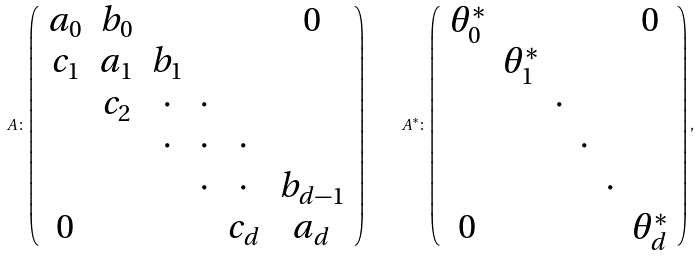<formula> <loc_0><loc_0><loc_500><loc_500>A \colon \left ( \begin{array} { c c c c c c } a _ { 0 } & b _ { 0 } & & & & { 0 } \\ c _ { 1 } & a _ { 1 } & b _ { 1 } & & & \\ & c _ { 2 } & \cdot & \cdot & & \\ & & \cdot & \cdot & \cdot & \\ & & & \cdot & \cdot & b _ { d - 1 } \\ { 0 } & & & & c _ { d } & a _ { d } \end{array} \right ) \quad A ^ { * } \colon \left ( \begin{array} { c c c c c c } \theta ^ { * } _ { 0 } & & & & & { 0 } \\ & \theta ^ { * } _ { 1 } & & & & \\ & & \cdot & & & \\ & & & \cdot & & \\ & & & & \cdot & \\ { 0 } & & & & & \theta ^ { * } _ { d } \end{array} \right ) ,</formula> 